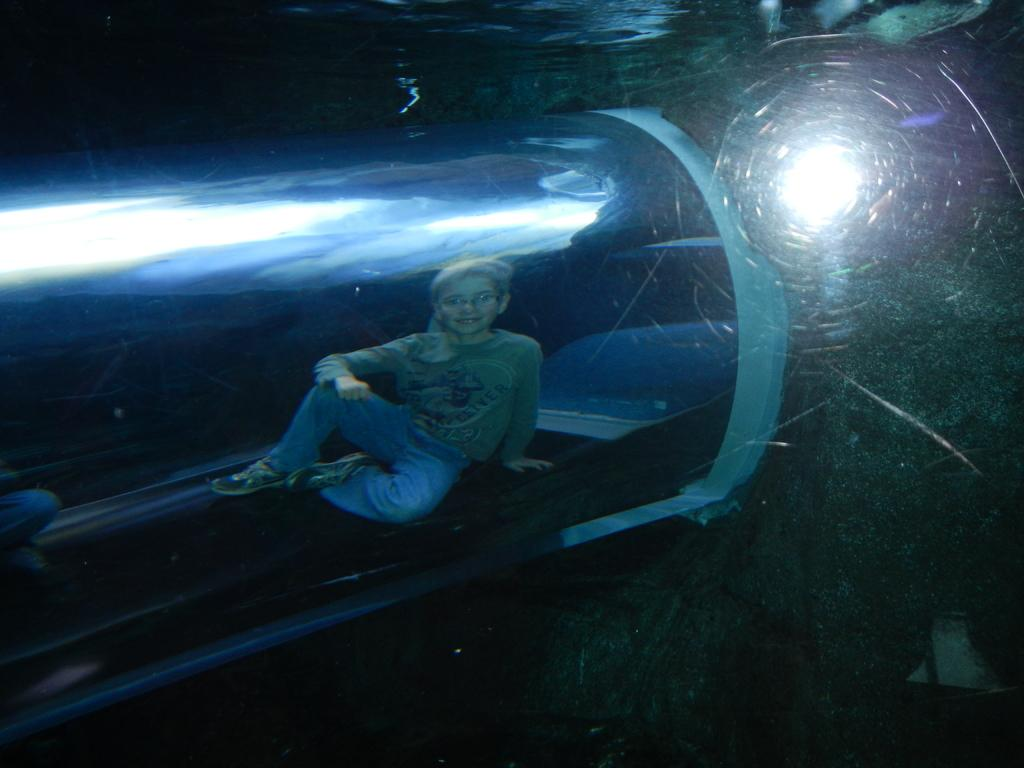Who or what is present in the image? There is a person in the image. Can you describe the person's surroundings? The person is sitting inside a transparent cubicle. What can be seen behind the person? There is a light visible behind the person. What degree does the person in the image hold? There is no information about the person's degree in the image. What position is the person in the image? The person is sitting in the image, but there is no information about their position or occupation. 